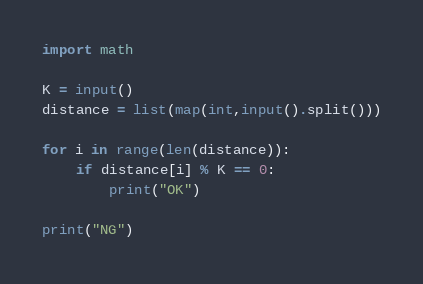<code> <loc_0><loc_0><loc_500><loc_500><_Python_>import math

K = input()
distance = list(map(int,input().split()))

for i in range(len(distance)):
    if distance[i] % K == 0:
        print("OK")

print("NG")</code> 